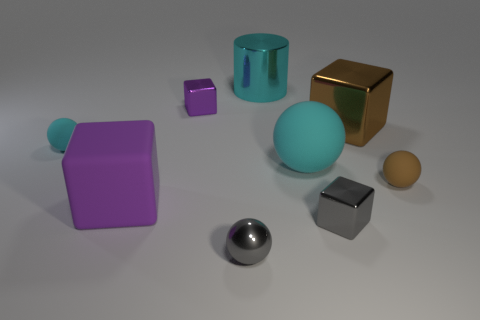What number of things are either tiny cubes that are on the left side of the tiny metal ball or small spheres?
Your answer should be very brief. 4. What number of objects are tiny gray blocks or purple blocks behind the tiny cyan object?
Keep it short and to the point. 2. There is a purple thing that is behind the cyan object on the right side of the cyan shiny cylinder; how many tiny gray balls are to the left of it?
Offer a very short reply. 0. There is a sphere that is the same size as the brown cube; what is its material?
Make the answer very short. Rubber. Are there any things that have the same size as the gray shiny block?
Make the answer very short. Yes. The metal cylinder is what color?
Make the answer very short. Cyan. There is a rubber ball in front of the cyan sphere that is in front of the small cyan matte ball; what is its color?
Provide a succinct answer. Brown. What shape is the big rubber thing to the left of the small gray object to the left of the metal cube in front of the large brown metal thing?
Provide a short and direct response. Cube. How many tiny cyan balls are the same material as the tiny brown thing?
Your answer should be very brief. 1. How many large purple matte blocks are behind the small rubber sphere that is on the left side of the gray ball?
Make the answer very short. 0. 